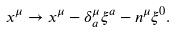<formula> <loc_0><loc_0><loc_500><loc_500>x ^ { \mu } \rightarrow x ^ { \mu } - \delta ^ { \mu } _ { a } \xi ^ { a } - n ^ { \mu } \xi ^ { 0 } .</formula> 